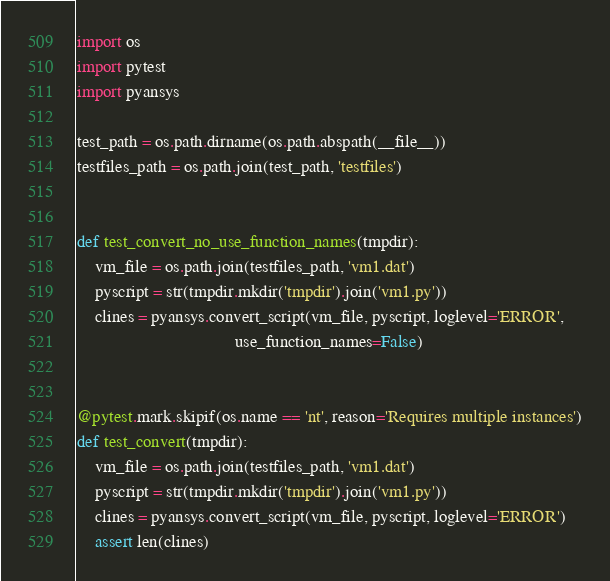<code> <loc_0><loc_0><loc_500><loc_500><_Python_>import os
import pytest
import pyansys

test_path = os.path.dirname(os.path.abspath(__file__))
testfiles_path = os.path.join(test_path, 'testfiles')


def test_convert_no_use_function_names(tmpdir):
    vm_file = os.path.join(testfiles_path, 'vm1.dat')
    pyscript = str(tmpdir.mkdir('tmpdir').join('vm1.py'))
    clines = pyansys.convert_script(vm_file, pyscript, loglevel='ERROR',
                                    use_function_names=False)


@pytest.mark.skipif(os.name == 'nt', reason='Requires multiple instances')
def test_convert(tmpdir):
    vm_file = os.path.join(testfiles_path, 'vm1.dat')
    pyscript = str(tmpdir.mkdir('tmpdir').join('vm1.py'))
    clines = pyansys.convert_script(vm_file, pyscript, loglevel='ERROR')
    assert len(clines)
</code> 